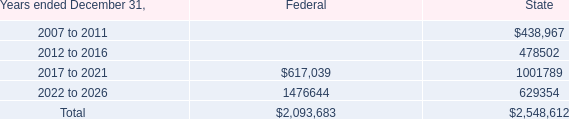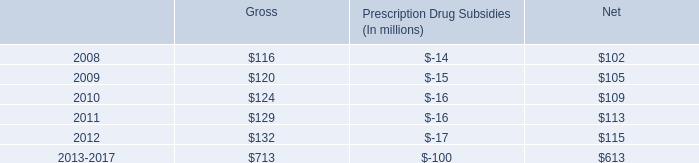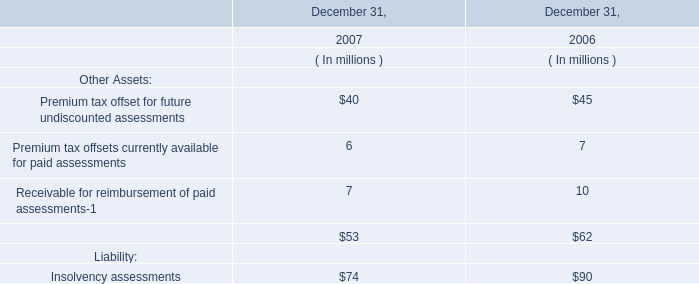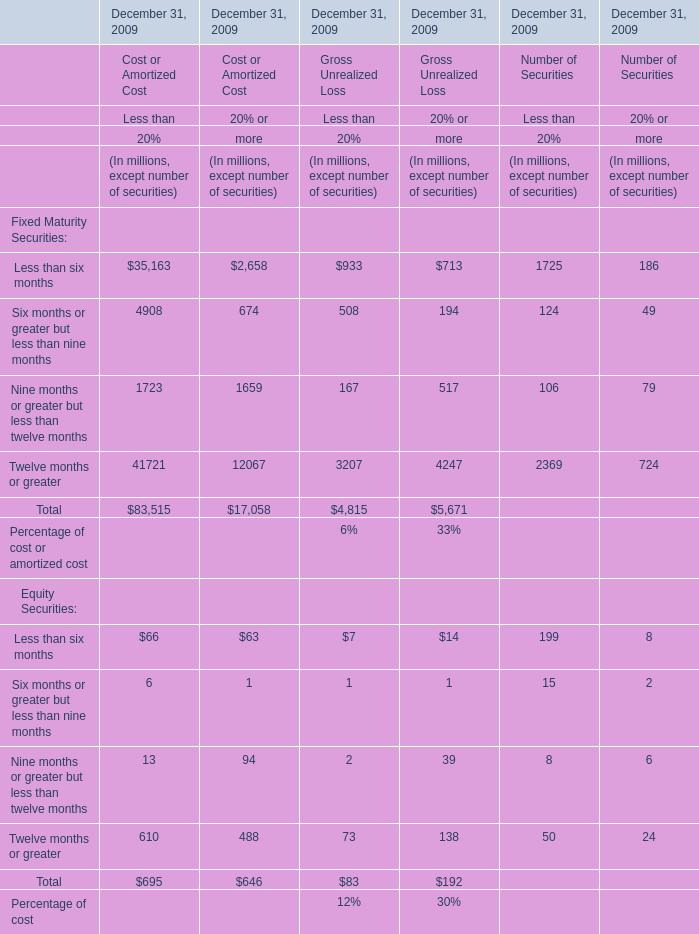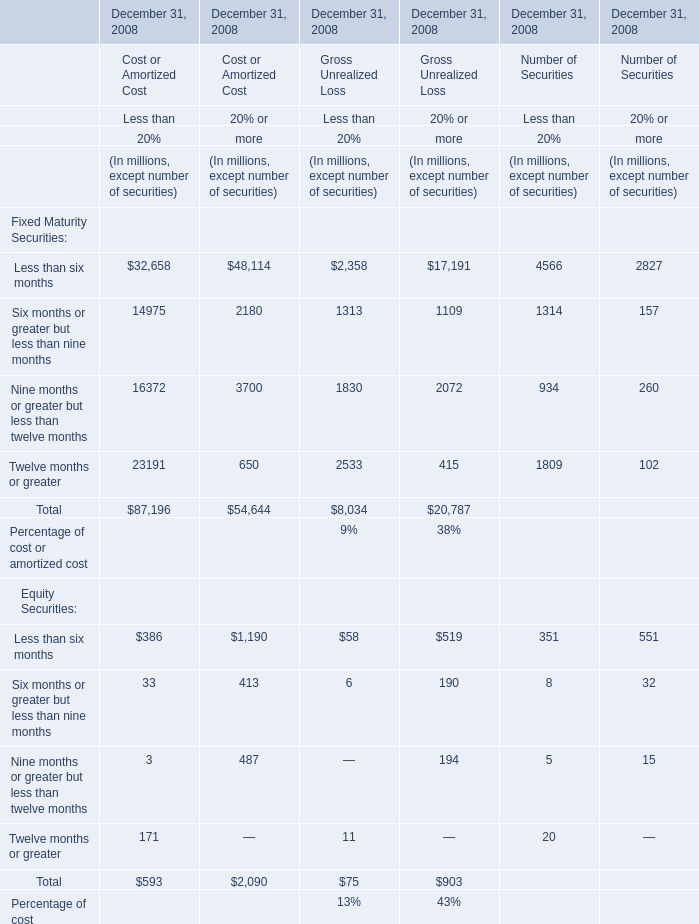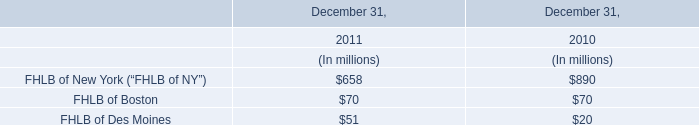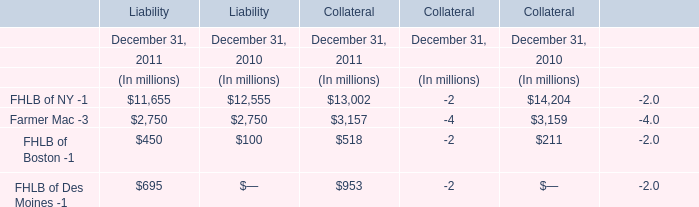In which section the sum of Cost or Amortized Cost for Fixed Maturity Securitie has the highest value? 
Answer: Twelve months or greater. 